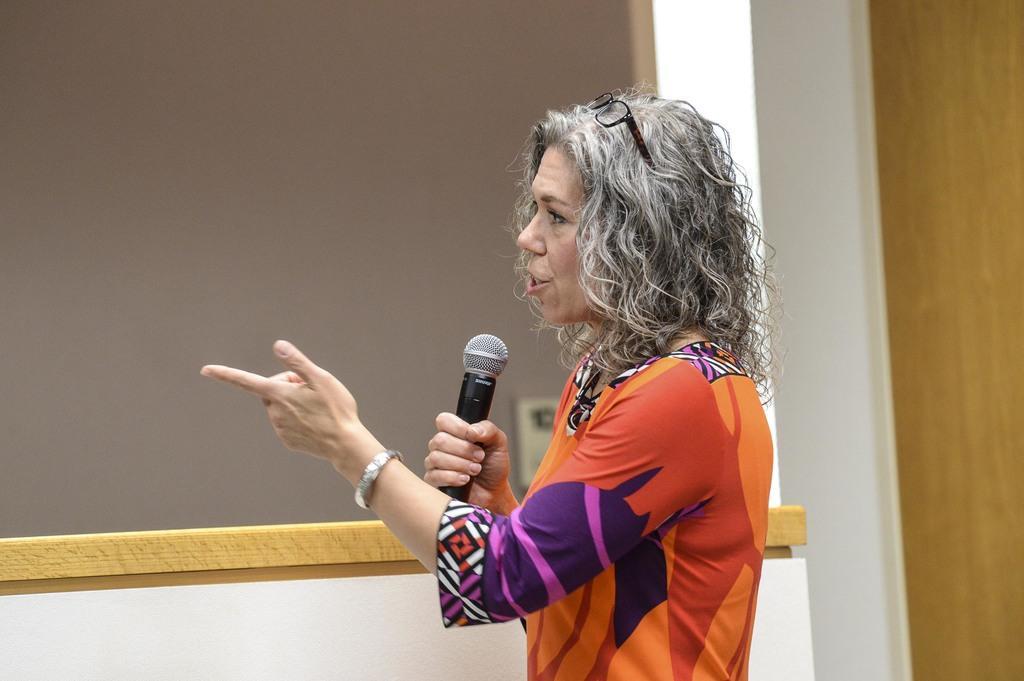Can you describe this image briefly? In this picture we can see a woman who is talking on the mike. On the background there is a wall. 